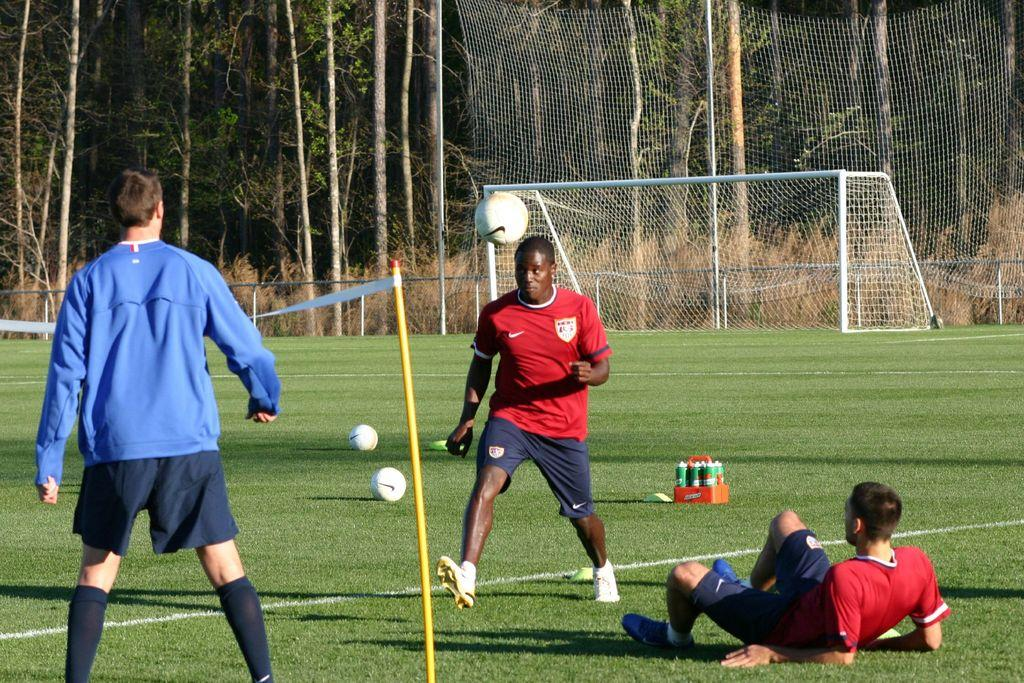What can be seen in the background of the image? There are trees and a net in the background of the image. What are the persons in the image doing? The persons in the image are playing with a ball. What type of location does the image appear to depict? The setting appears to be a playground. What items are related to refreshments or hydration in the image? There are bottles in a case in the image. What shape does the spring take in the image? There is no spring present in the image. How does the increase in the number of persons playing with the ball affect the game? The number of persons playing with the ball is not mentioned in the image, so it cannot be determined how an increase would affect the game. 